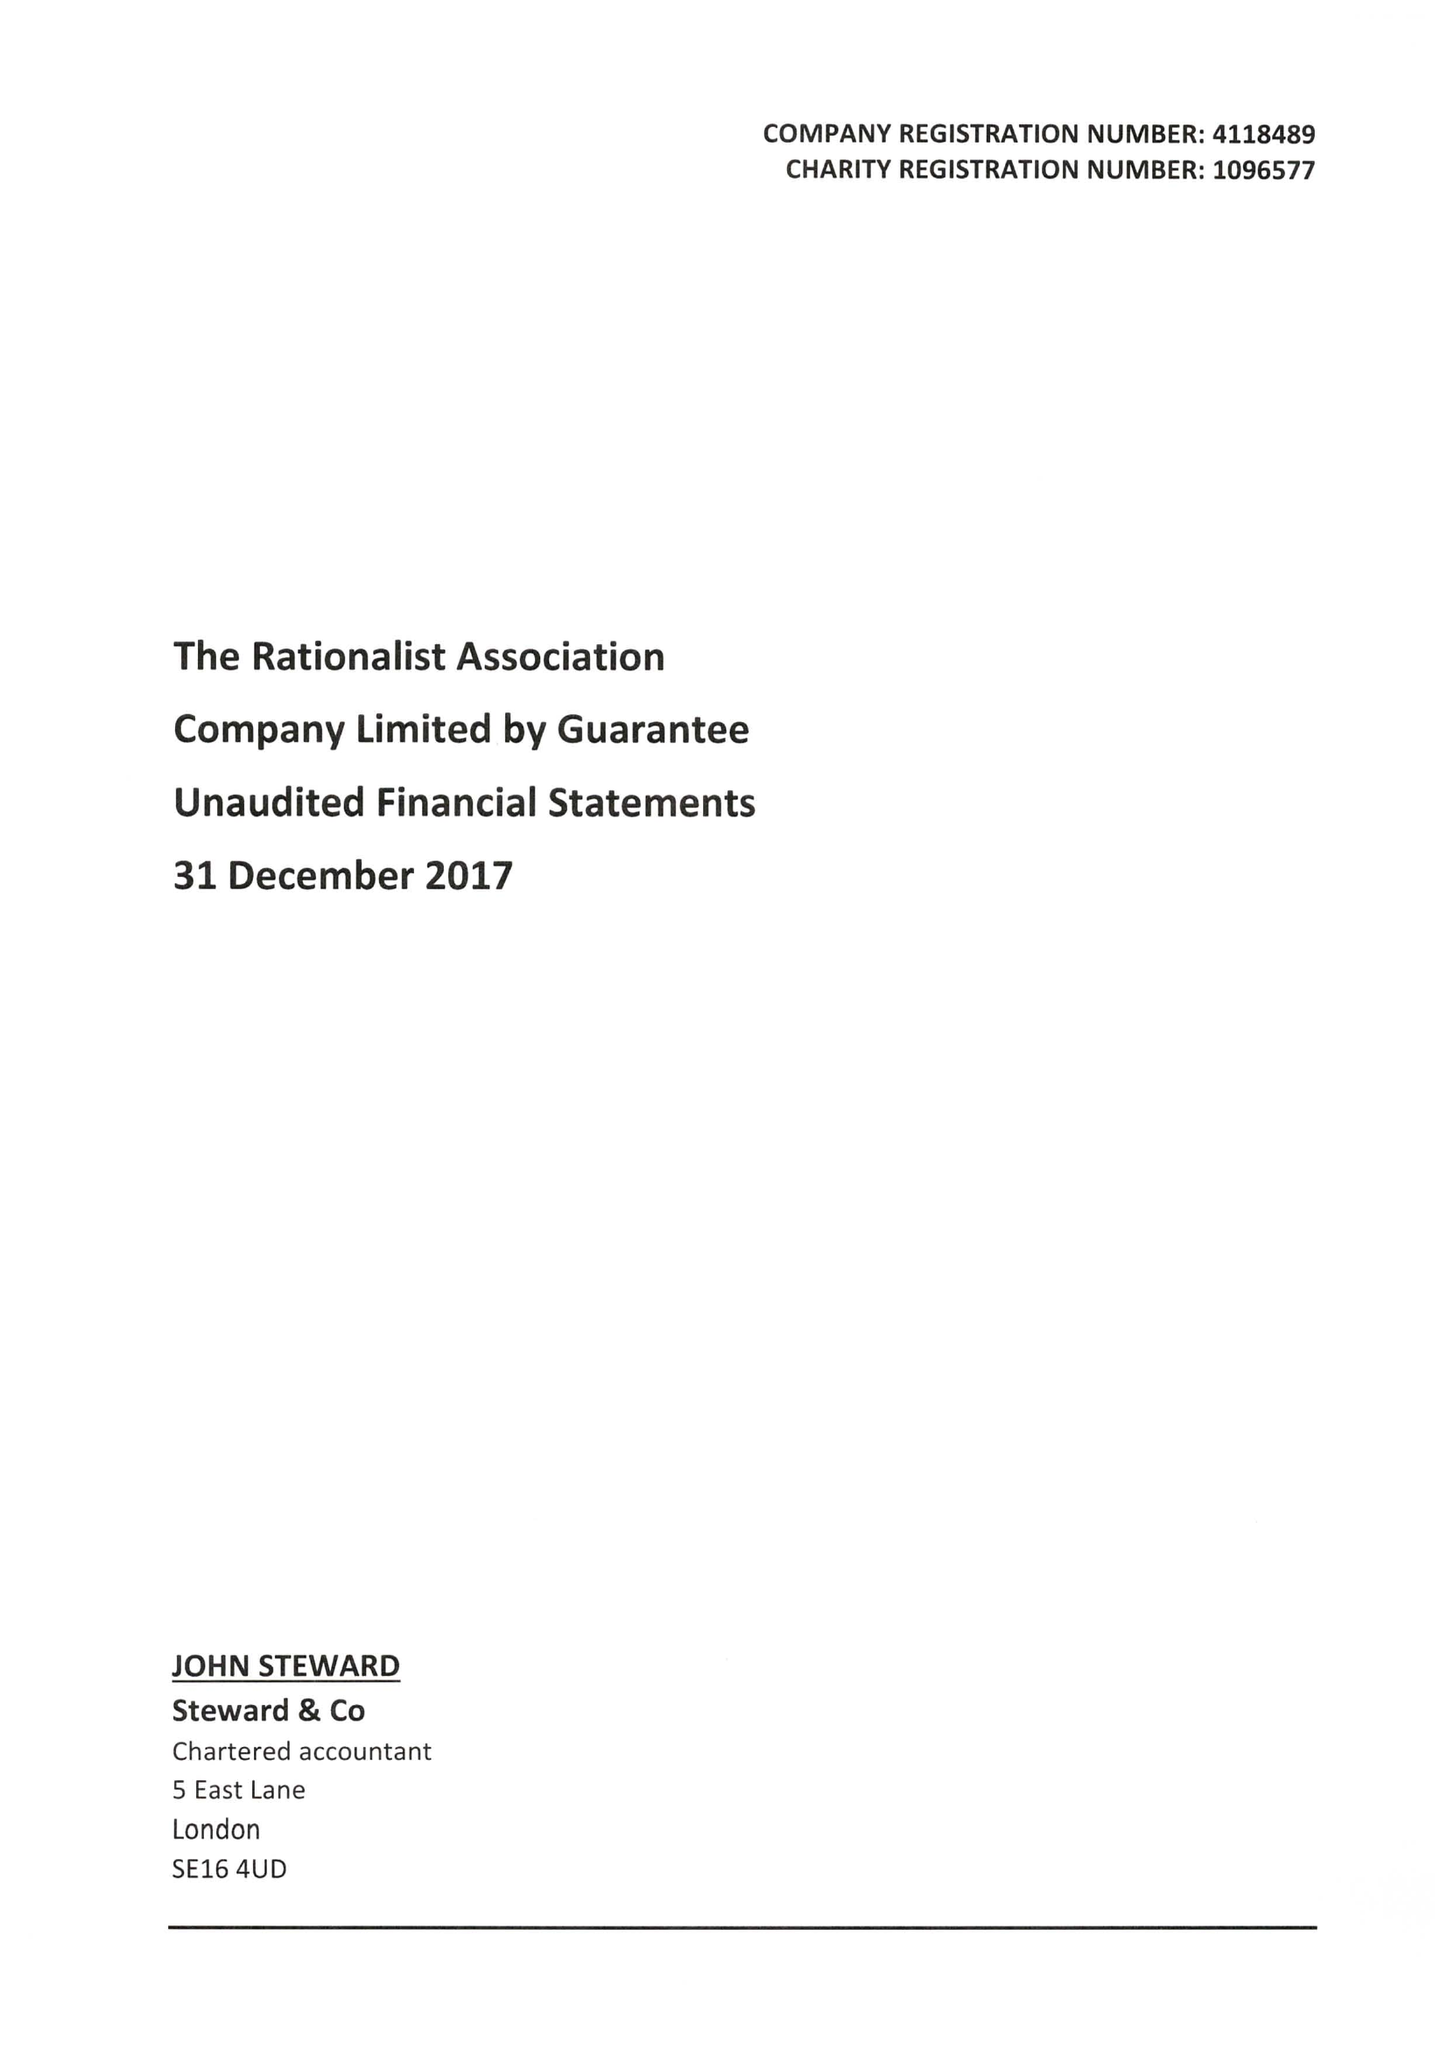What is the value for the charity_name?
Answer the question using a single word or phrase. The Rationalist Association 